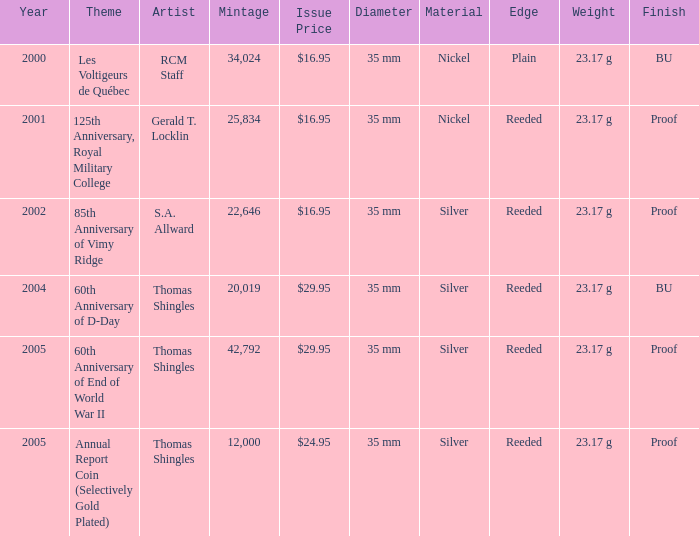What year was S.A. Allward's theme that had an issue price of $16.95 released? 2002.0. 